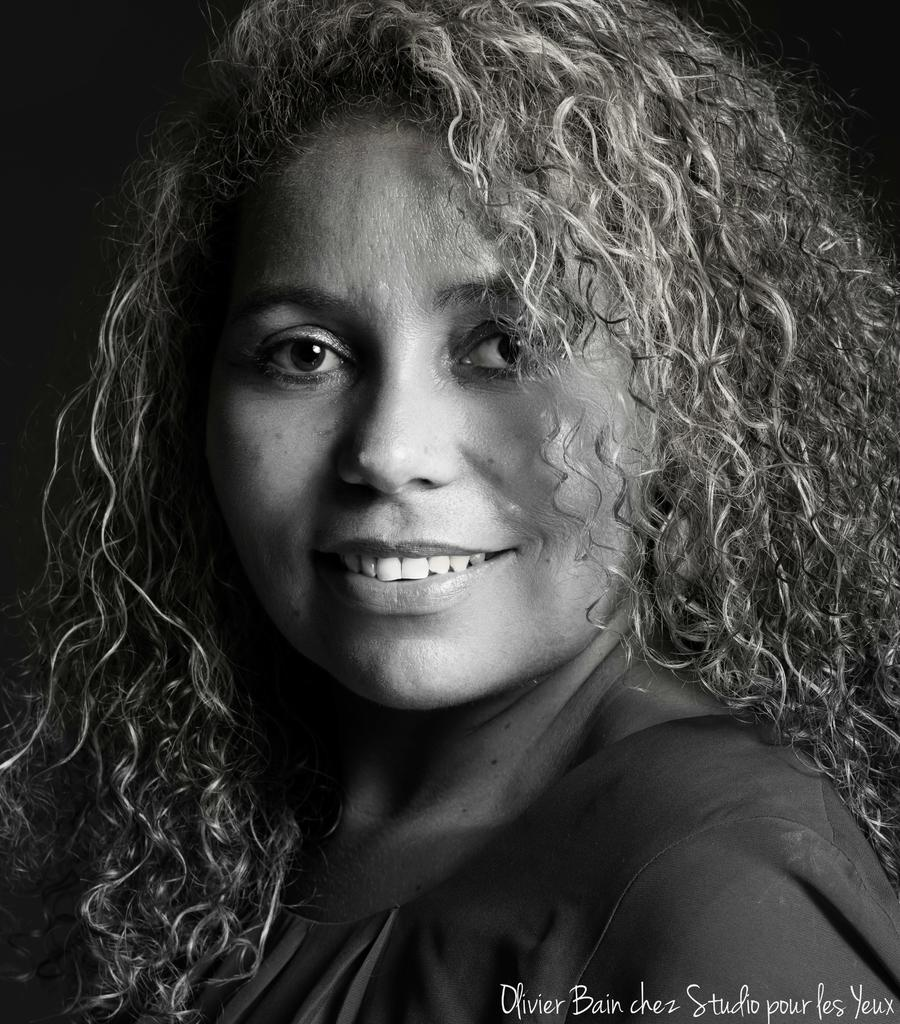Who is present in the image? There is a woman in the image. What is the woman doing in the image? The woman is smiling in the image. Can you describe any text or writing visible in the image? Yes, there is text or writing visible in the bottom right side of the image. What type of street is visible in the background of the image? There is no street visible in the background of the image. Can you describe the woman's partner in the image? There is no partner present in the image; only the woman is visible. 